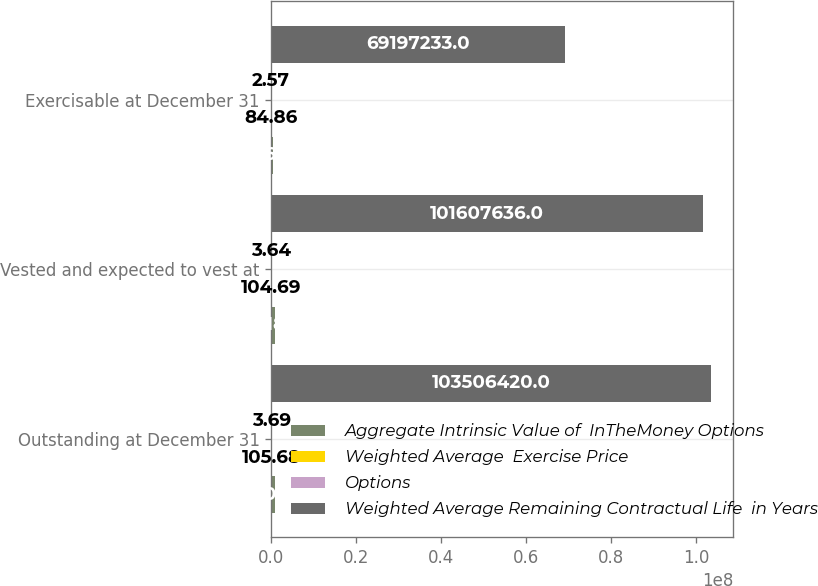<chart> <loc_0><loc_0><loc_500><loc_500><stacked_bar_chart><ecel><fcel>Outstanding at December 31<fcel>Vested and expected to vest at<fcel>Exercisable at December 31<nl><fcel>Aggregate Intrinsic Value of  InTheMoney Options<fcel>808049<fcel>787182<fcel>464685<nl><fcel>Weighted Average  Exercise Price<fcel>105.68<fcel>104.69<fcel>84.86<nl><fcel>Options<fcel>3.69<fcel>3.64<fcel>2.57<nl><fcel>Weighted Average Remaining Contractual Life  in Years<fcel>1.03506e+08<fcel>1.01608e+08<fcel>6.91972e+07<nl></chart> 